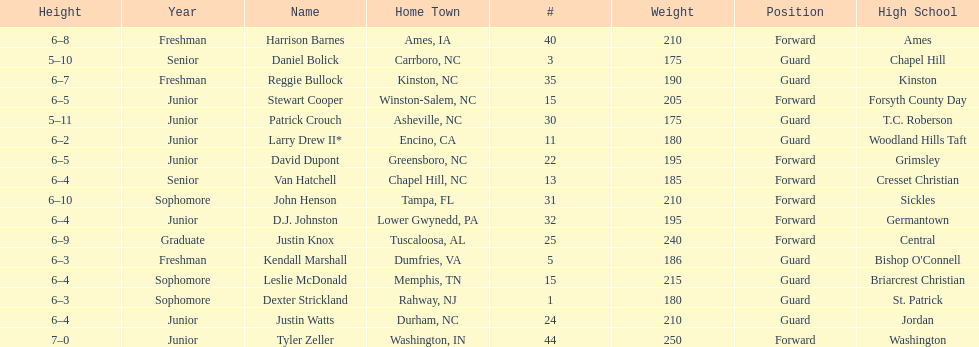How many players were taller than van hatchell? 7. 